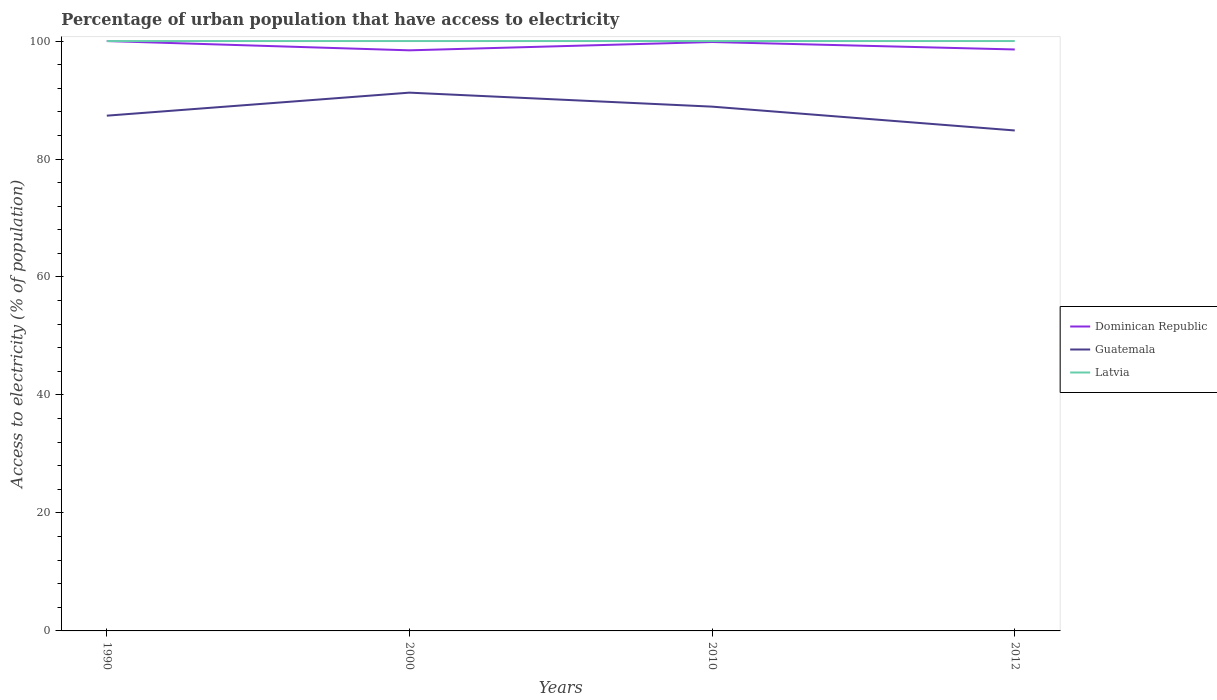How many different coloured lines are there?
Make the answer very short. 3. Is the number of lines equal to the number of legend labels?
Your answer should be very brief. Yes. Across all years, what is the maximum percentage of urban population that have access to electricity in Guatemala?
Provide a short and direct response. 84.84. In which year was the percentage of urban population that have access to electricity in Guatemala maximum?
Your response must be concise. 2012. What is the difference between the highest and the second highest percentage of urban population that have access to electricity in Latvia?
Offer a terse response. 0. What is the difference between the highest and the lowest percentage of urban population that have access to electricity in Dominican Republic?
Your answer should be compact. 2. Is the percentage of urban population that have access to electricity in Latvia strictly greater than the percentage of urban population that have access to electricity in Guatemala over the years?
Offer a very short reply. No. Are the values on the major ticks of Y-axis written in scientific E-notation?
Your response must be concise. No. How many legend labels are there?
Ensure brevity in your answer.  3. What is the title of the graph?
Ensure brevity in your answer.  Percentage of urban population that have access to electricity. What is the label or title of the X-axis?
Your answer should be very brief. Years. What is the label or title of the Y-axis?
Your answer should be compact. Access to electricity (% of population). What is the Access to electricity (% of population) of Guatemala in 1990?
Offer a very short reply. 87.35. What is the Access to electricity (% of population) of Latvia in 1990?
Offer a terse response. 100. What is the Access to electricity (% of population) of Dominican Republic in 2000?
Offer a very short reply. 98.43. What is the Access to electricity (% of population) in Guatemala in 2000?
Your answer should be compact. 91.25. What is the Access to electricity (% of population) of Dominican Republic in 2010?
Keep it short and to the point. 99.84. What is the Access to electricity (% of population) of Guatemala in 2010?
Your answer should be very brief. 88.88. What is the Access to electricity (% of population) of Dominican Republic in 2012?
Offer a terse response. 98.57. What is the Access to electricity (% of population) in Guatemala in 2012?
Your answer should be compact. 84.84. Across all years, what is the maximum Access to electricity (% of population) of Guatemala?
Give a very brief answer. 91.25. Across all years, what is the minimum Access to electricity (% of population) in Dominican Republic?
Give a very brief answer. 98.43. Across all years, what is the minimum Access to electricity (% of population) in Guatemala?
Your answer should be very brief. 84.84. What is the total Access to electricity (% of population) in Dominican Republic in the graph?
Provide a succinct answer. 396.83. What is the total Access to electricity (% of population) in Guatemala in the graph?
Your response must be concise. 352.32. What is the total Access to electricity (% of population) in Latvia in the graph?
Ensure brevity in your answer.  400. What is the difference between the Access to electricity (% of population) of Dominican Republic in 1990 and that in 2000?
Keep it short and to the point. 1.57. What is the difference between the Access to electricity (% of population) in Guatemala in 1990 and that in 2000?
Your response must be concise. -3.91. What is the difference between the Access to electricity (% of population) of Dominican Republic in 1990 and that in 2010?
Ensure brevity in your answer.  0.16. What is the difference between the Access to electricity (% of population) in Guatemala in 1990 and that in 2010?
Provide a short and direct response. -1.53. What is the difference between the Access to electricity (% of population) in Dominican Republic in 1990 and that in 2012?
Provide a short and direct response. 1.43. What is the difference between the Access to electricity (% of population) of Guatemala in 1990 and that in 2012?
Provide a short and direct response. 2.51. What is the difference between the Access to electricity (% of population) of Dominican Republic in 2000 and that in 2010?
Offer a terse response. -1.41. What is the difference between the Access to electricity (% of population) of Guatemala in 2000 and that in 2010?
Offer a very short reply. 2.37. What is the difference between the Access to electricity (% of population) of Latvia in 2000 and that in 2010?
Offer a terse response. 0. What is the difference between the Access to electricity (% of population) in Dominican Republic in 2000 and that in 2012?
Ensure brevity in your answer.  -0.15. What is the difference between the Access to electricity (% of population) in Guatemala in 2000 and that in 2012?
Your answer should be very brief. 6.41. What is the difference between the Access to electricity (% of population) in Latvia in 2000 and that in 2012?
Keep it short and to the point. 0. What is the difference between the Access to electricity (% of population) in Dominican Republic in 2010 and that in 2012?
Your answer should be compact. 1.26. What is the difference between the Access to electricity (% of population) of Guatemala in 2010 and that in 2012?
Provide a short and direct response. 4.04. What is the difference between the Access to electricity (% of population) in Latvia in 2010 and that in 2012?
Provide a succinct answer. 0. What is the difference between the Access to electricity (% of population) of Dominican Republic in 1990 and the Access to electricity (% of population) of Guatemala in 2000?
Offer a terse response. 8.75. What is the difference between the Access to electricity (% of population) in Dominican Republic in 1990 and the Access to electricity (% of population) in Latvia in 2000?
Your response must be concise. 0. What is the difference between the Access to electricity (% of population) of Guatemala in 1990 and the Access to electricity (% of population) of Latvia in 2000?
Provide a short and direct response. -12.65. What is the difference between the Access to electricity (% of population) in Dominican Republic in 1990 and the Access to electricity (% of population) in Guatemala in 2010?
Your answer should be compact. 11.12. What is the difference between the Access to electricity (% of population) in Guatemala in 1990 and the Access to electricity (% of population) in Latvia in 2010?
Make the answer very short. -12.65. What is the difference between the Access to electricity (% of population) in Dominican Republic in 1990 and the Access to electricity (% of population) in Guatemala in 2012?
Provide a short and direct response. 15.16. What is the difference between the Access to electricity (% of population) of Dominican Republic in 1990 and the Access to electricity (% of population) of Latvia in 2012?
Offer a terse response. 0. What is the difference between the Access to electricity (% of population) of Guatemala in 1990 and the Access to electricity (% of population) of Latvia in 2012?
Make the answer very short. -12.65. What is the difference between the Access to electricity (% of population) in Dominican Republic in 2000 and the Access to electricity (% of population) in Guatemala in 2010?
Ensure brevity in your answer.  9.55. What is the difference between the Access to electricity (% of population) of Dominican Republic in 2000 and the Access to electricity (% of population) of Latvia in 2010?
Provide a short and direct response. -1.57. What is the difference between the Access to electricity (% of population) of Guatemala in 2000 and the Access to electricity (% of population) of Latvia in 2010?
Keep it short and to the point. -8.75. What is the difference between the Access to electricity (% of population) in Dominican Republic in 2000 and the Access to electricity (% of population) in Guatemala in 2012?
Provide a succinct answer. 13.59. What is the difference between the Access to electricity (% of population) of Dominican Republic in 2000 and the Access to electricity (% of population) of Latvia in 2012?
Your answer should be very brief. -1.57. What is the difference between the Access to electricity (% of population) of Guatemala in 2000 and the Access to electricity (% of population) of Latvia in 2012?
Make the answer very short. -8.75. What is the difference between the Access to electricity (% of population) in Dominican Republic in 2010 and the Access to electricity (% of population) in Guatemala in 2012?
Keep it short and to the point. 15. What is the difference between the Access to electricity (% of population) of Dominican Republic in 2010 and the Access to electricity (% of population) of Latvia in 2012?
Your answer should be compact. -0.16. What is the difference between the Access to electricity (% of population) of Guatemala in 2010 and the Access to electricity (% of population) of Latvia in 2012?
Make the answer very short. -11.12. What is the average Access to electricity (% of population) in Dominican Republic per year?
Provide a short and direct response. 99.21. What is the average Access to electricity (% of population) in Guatemala per year?
Provide a succinct answer. 88.08. In the year 1990, what is the difference between the Access to electricity (% of population) in Dominican Republic and Access to electricity (% of population) in Guatemala?
Ensure brevity in your answer.  12.65. In the year 1990, what is the difference between the Access to electricity (% of population) of Dominican Republic and Access to electricity (% of population) of Latvia?
Ensure brevity in your answer.  0. In the year 1990, what is the difference between the Access to electricity (% of population) of Guatemala and Access to electricity (% of population) of Latvia?
Offer a very short reply. -12.65. In the year 2000, what is the difference between the Access to electricity (% of population) in Dominican Republic and Access to electricity (% of population) in Guatemala?
Provide a short and direct response. 7.17. In the year 2000, what is the difference between the Access to electricity (% of population) of Dominican Republic and Access to electricity (% of population) of Latvia?
Your answer should be compact. -1.57. In the year 2000, what is the difference between the Access to electricity (% of population) in Guatemala and Access to electricity (% of population) in Latvia?
Provide a succinct answer. -8.75. In the year 2010, what is the difference between the Access to electricity (% of population) of Dominican Republic and Access to electricity (% of population) of Guatemala?
Your answer should be compact. 10.96. In the year 2010, what is the difference between the Access to electricity (% of population) in Dominican Republic and Access to electricity (% of population) in Latvia?
Keep it short and to the point. -0.16. In the year 2010, what is the difference between the Access to electricity (% of population) in Guatemala and Access to electricity (% of population) in Latvia?
Your answer should be very brief. -11.12. In the year 2012, what is the difference between the Access to electricity (% of population) in Dominican Republic and Access to electricity (% of population) in Guatemala?
Offer a very short reply. 13.73. In the year 2012, what is the difference between the Access to electricity (% of population) of Dominican Republic and Access to electricity (% of population) of Latvia?
Your answer should be compact. -1.43. In the year 2012, what is the difference between the Access to electricity (% of population) in Guatemala and Access to electricity (% of population) in Latvia?
Make the answer very short. -15.16. What is the ratio of the Access to electricity (% of population) of Dominican Republic in 1990 to that in 2000?
Keep it short and to the point. 1.02. What is the ratio of the Access to electricity (% of population) in Guatemala in 1990 to that in 2000?
Make the answer very short. 0.96. What is the ratio of the Access to electricity (% of population) of Guatemala in 1990 to that in 2010?
Keep it short and to the point. 0.98. What is the ratio of the Access to electricity (% of population) of Dominican Republic in 1990 to that in 2012?
Make the answer very short. 1.01. What is the ratio of the Access to electricity (% of population) in Guatemala in 1990 to that in 2012?
Offer a very short reply. 1.03. What is the ratio of the Access to electricity (% of population) of Dominican Republic in 2000 to that in 2010?
Your answer should be very brief. 0.99. What is the ratio of the Access to electricity (% of population) in Guatemala in 2000 to that in 2010?
Your response must be concise. 1.03. What is the ratio of the Access to electricity (% of population) in Dominican Republic in 2000 to that in 2012?
Make the answer very short. 1. What is the ratio of the Access to electricity (% of population) in Guatemala in 2000 to that in 2012?
Your answer should be very brief. 1.08. What is the ratio of the Access to electricity (% of population) of Dominican Republic in 2010 to that in 2012?
Provide a succinct answer. 1.01. What is the ratio of the Access to electricity (% of population) in Guatemala in 2010 to that in 2012?
Keep it short and to the point. 1.05. What is the difference between the highest and the second highest Access to electricity (% of population) of Dominican Republic?
Provide a succinct answer. 0.16. What is the difference between the highest and the second highest Access to electricity (% of population) of Guatemala?
Your response must be concise. 2.37. What is the difference between the highest and the second highest Access to electricity (% of population) in Latvia?
Your response must be concise. 0. What is the difference between the highest and the lowest Access to electricity (% of population) of Dominican Republic?
Provide a short and direct response. 1.57. What is the difference between the highest and the lowest Access to electricity (% of population) of Guatemala?
Your response must be concise. 6.41. 